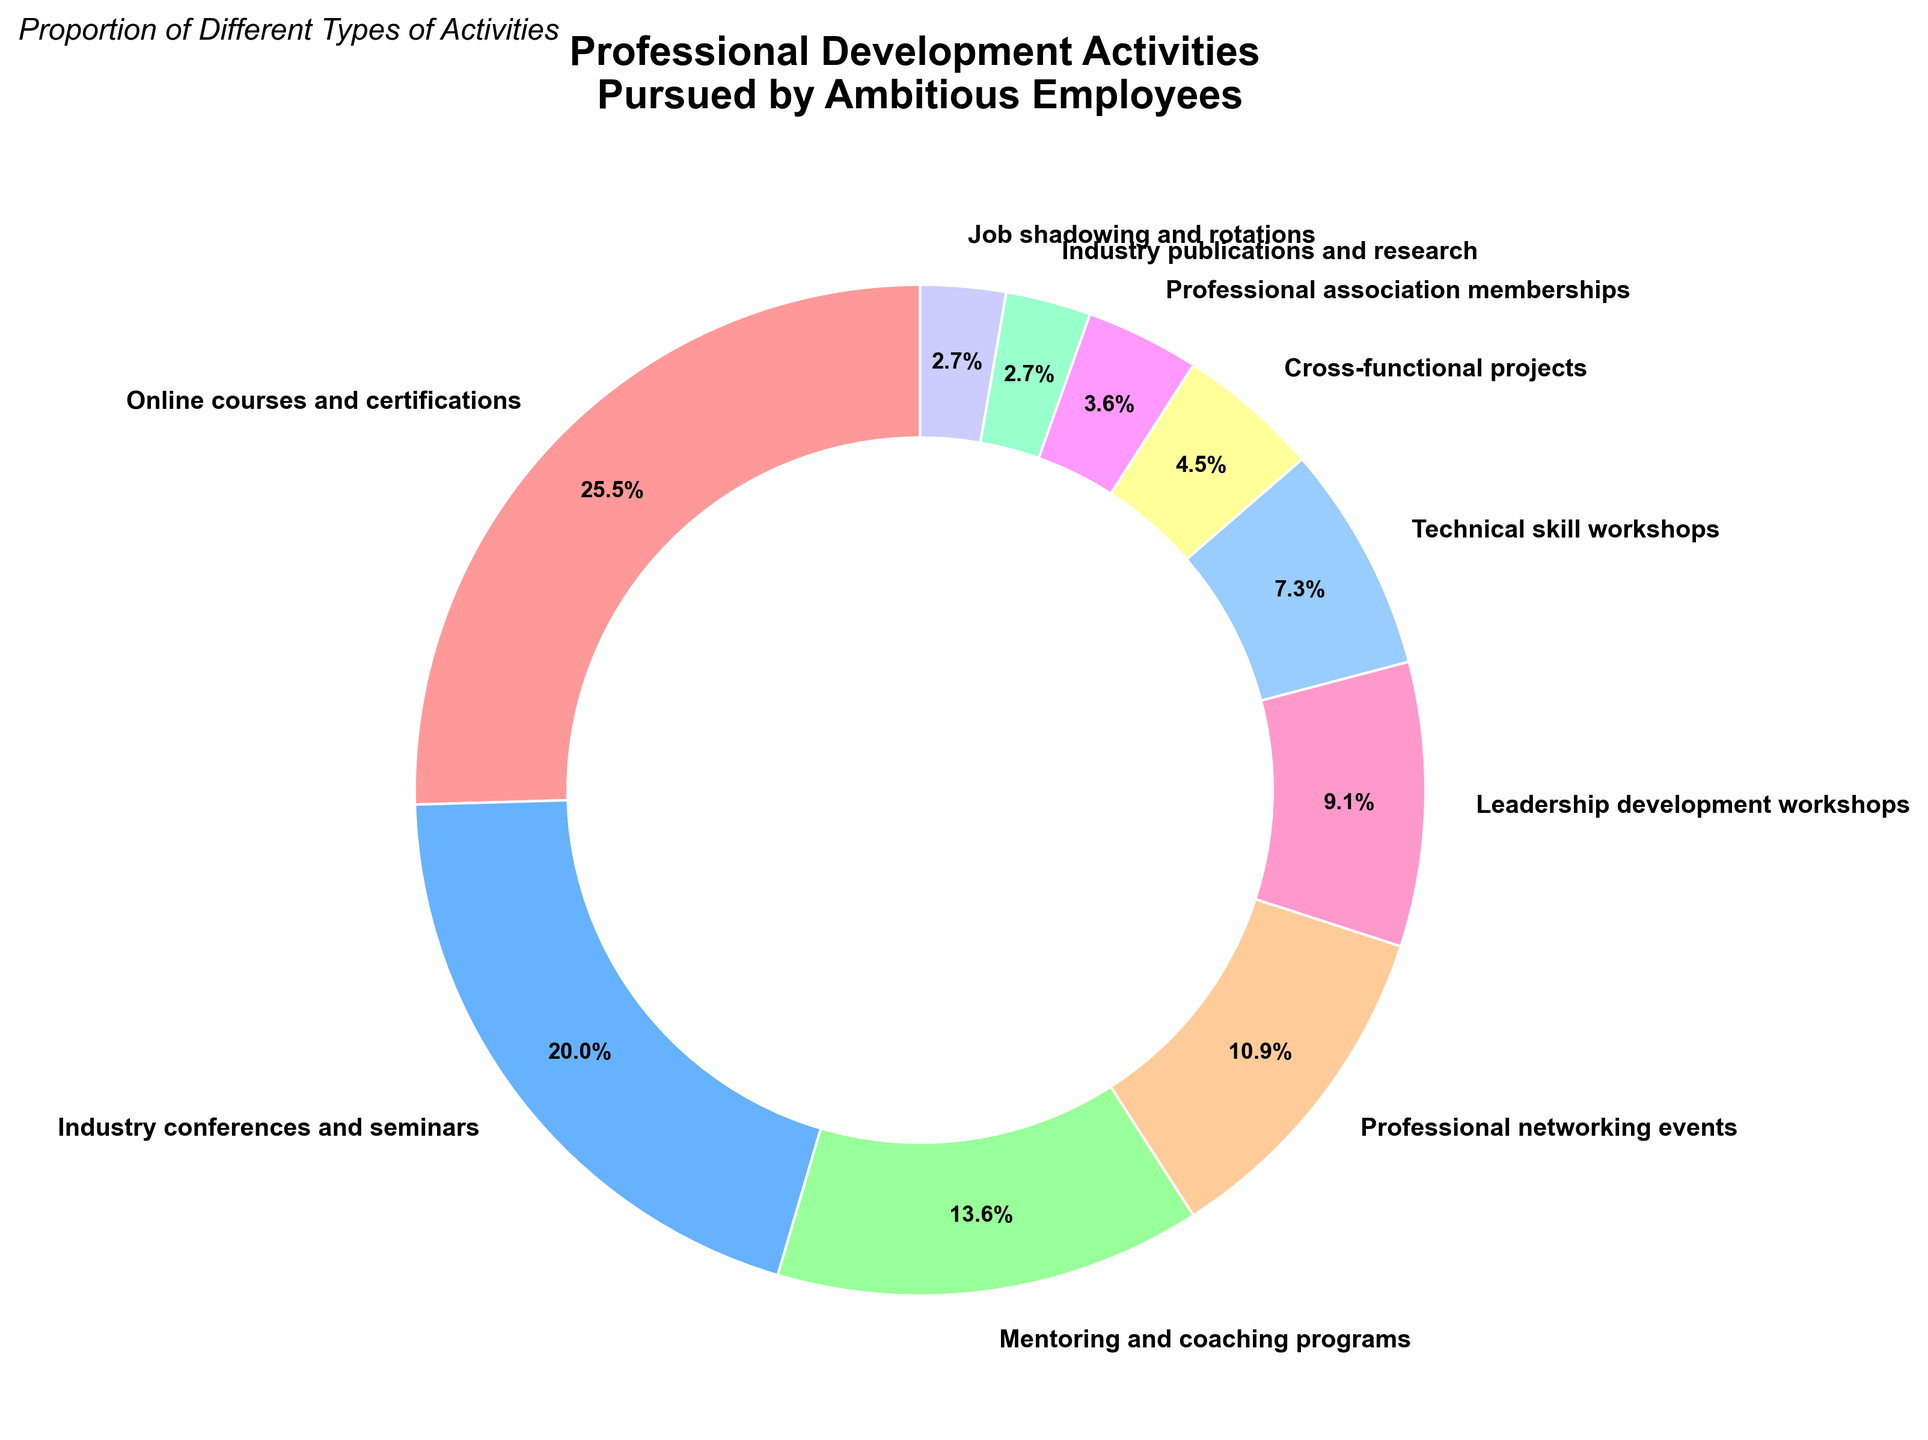What is the proportion of employees pursuing online courses and certifications? Referring to the pie chart, we find that the proportion of employees pursuing online courses and certifications is shown at 28%.
Answer: 28% Which category has a larger percentage: mentoring and coaching programs or leadership development workshops? By comparing the percentages in the pie chart, we see that mentoring and coaching programs have a percentage of 15% while leadership development workshops have a percentage of 10%, making mentoring and coaching programs larger.
Answer: Mentoring and coaching programs What is the combined percentage of employees participating in industry conferences and seminars, and professional networking events? From the pie chart, industry conferences and seminars account for 22%, and professional networking events account for 12%. Adding these together, the combined percentage is 22% + 12% = 34%.
Answer: 34% Which activity occupies the smallest portion of the pie chart? On visual inspection, job shadowing and rotations and industry publications and research each occupy the smallest portion of the pie chart, both showing a percentage of 3%.
Answer: Job shadowing and rotations, Industry publications and research How much more popular are online courses and certifications compared to technical skill workshops? The proportion of online courses and certifications is 28% and technical skill workshops are 8%. The difference is 28% - 8% = 20%. Therefore, online courses and certifications are 20 percentage points more popular.
Answer: 20% What color represents cross-functional projects in the pie chart? Cross-functional projects are represented by a distinct visual color. Referring to the chart's labels and color scheme, cross-functional projects are shown in yellow.
Answer: Yellow Which three activities combined have the highest total percentage? The three activities with the highest individual percentages are online courses and certifications (28%), industry conferences and seminars (22%), and mentoring and coaching programs (15%). Together, they total 28% + 22% + 15% = 65%.
Answer: Online courses and certifications, Industry conferences and seminars, Mentoring and coaching programs Are the proportions of professional association memberships and job shadowing and rotations equal? Observing the pie chart, professional association memberships account for 4%, while job shadowing and rotations account for 3%. Therefore, the proportions are not equal.
Answer: No What is the average percentage of the activities excluding the highest and lowest proportions? Exclude the highest (Online courses and certifications - 28%) and the lowest (Job shadowing and rotations and Industry publications and research - 3%). The remaining percentages are: 22+15+12+10+8+5+4. Sum these values to get 76 and divide by 7 (number of activities): 76 / 7 ≈ 10.86%.
Answer: 10.86% 